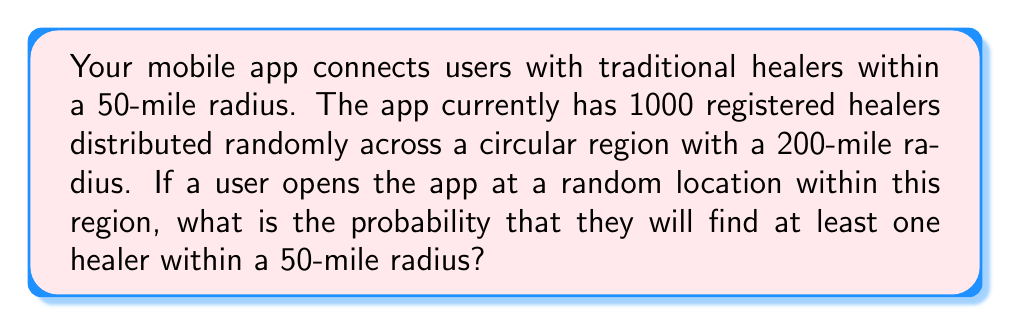What is the answer to this math problem? To solve this problem, we need to follow these steps:

1. Calculate the total area of the region:
   $$A_{total} = \pi r^2 = \pi (200)^2 = 40000\pi \text{ sq miles}$$

2. Calculate the area within which a healer must be located to be within 50 miles of the user:
   $$A_{user} = \pi r^2 = \pi (50)^2 = 2500\pi \text{ sq miles}$$

3. Calculate the probability that a single healer is within the user's radius:
   $$P(\text{healer within radius}) = \frac{A_{user}}{A_{total}} = \frac{2500\pi}{40000\pi} = \frac{1}{16}$$

4. Calculate the probability that a healer is not within the user's radius:
   $$P(\text{healer not within radius}) = 1 - \frac{1}{16} = \frac{15}{16}$$

5. Calculate the probability that none of the 1000 healers are within the user's radius:
   $$P(\text{no healers within radius}) = \left(\frac{15}{16}\right)^{1000}$$

6. Calculate the probability that at least one healer is within the user's radius:
   $$P(\text{at least one healer within radius}) = 1 - P(\text{no healers within radius})$$
   $$= 1 - \left(\frac{15}{16}\right)^{1000}$$

7. Evaluate the final expression:
   $$1 - \left(\frac{15}{16}\right)^{1000} \approx 0.9999999999999999$$
Answer: The probability that a user will find at least one healer within a 50-mile radius is approximately 0.9999999999999999 or 99.99999999999999%. 